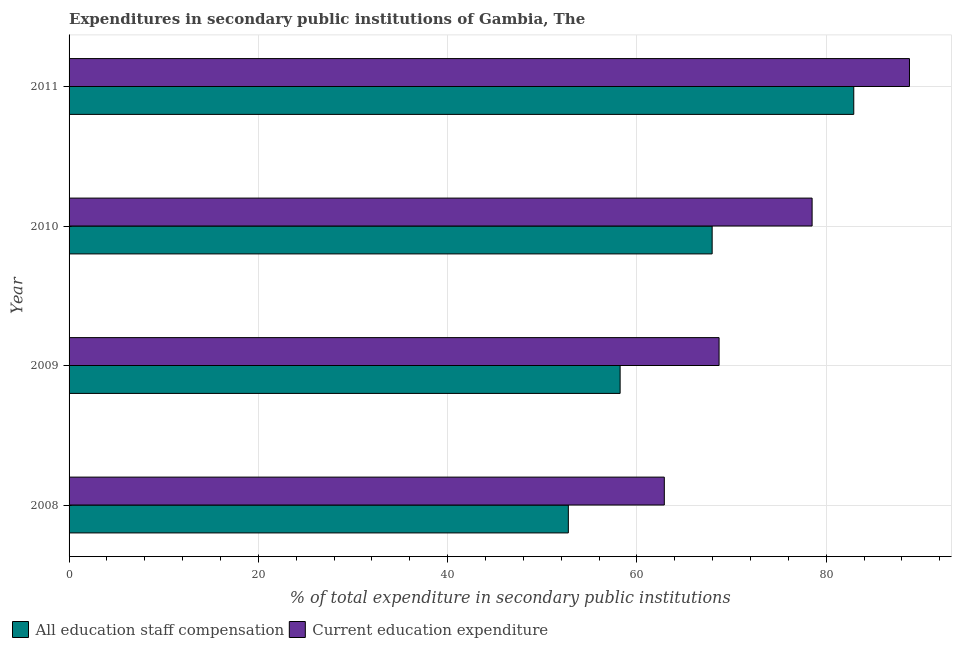Are the number of bars per tick equal to the number of legend labels?
Make the answer very short. Yes. How many bars are there on the 4th tick from the top?
Give a very brief answer. 2. How many bars are there on the 4th tick from the bottom?
Give a very brief answer. 2. What is the expenditure in education in 2009?
Your response must be concise. 68.69. Across all years, what is the maximum expenditure in staff compensation?
Your response must be concise. 82.92. Across all years, what is the minimum expenditure in education?
Provide a short and direct response. 62.9. In which year was the expenditure in education maximum?
Offer a terse response. 2011. What is the total expenditure in staff compensation in the graph?
Your answer should be very brief. 261.86. What is the difference between the expenditure in education in 2009 and that in 2010?
Offer a terse response. -9.83. What is the difference between the expenditure in education in 2011 and the expenditure in staff compensation in 2008?
Make the answer very short. 36.05. What is the average expenditure in staff compensation per year?
Keep it short and to the point. 65.47. In the year 2008, what is the difference between the expenditure in staff compensation and expenditure in education?
Your response must be concise. -10.14. What is the ratio of the expenditure in education in 2009 to that in 2011?
Provide a succinct answer. 0.77. Is the expenditure in education in 2008 less than that in 2009?
Your answer should be very brief. Yes. What is the difference between the highest and the second highest expenditure in education?
Provide a short and direct response. 10.29. What is the difference between the highest and the lowest expenditure in staff compensation?
Give a very brief answer. 30.16. In how many years, is the expenditure in education greater than the average expenditure in education taken over all years?
Make the answer very short. 2. What does the 1st bar from the top in 2009 represents?
Your answer should be very brief. Current education expenditure. What does the 1st bar from the bottom in 2008 represents?
Your answer should be compact. All education staff compensation. How many bars are there?
Offer a terse response. 8. How many years are there in the graph?
Your answer should be very brief. 4. What is the difference between two consecutive major ticks on the X-axis?
Your answer should be compact. 20. Where does the legend appear in the graph?
Your response must be concise. Bottom left. How many legend labels are there?
Offer a terse response. 2. What is the title of the graph?
Give a very brief answer. Expenditures in secondary public institutions of Gambia, The. What is the label or title of the X-axis?
Your answer should be very brief. % of total expenditure in secondary public institutions. What is the label or title of the Y-axis?
Keep it short and to the point. Year. What is the % of total expenditure in secondary public institutions of All education staff compensation in 2008?
Provide a short and direct response. 52.76. What is the % of total expenditure in secondary public institutions of Current education expenditure in 2008?
Your answer should be compact. 62.9. What is the % of total expenditure in secondary public institutions in All education staff compensation in 2009?
Give a very brief answer. 58.23. What is the % of total expenditure in secondary public institutions of Current education expenditure in 2009?
Keep it short and to the point. 68.69. What is the % of total expenditure in secondary public institutions in All education staff compensation in 2010?
Your response must be concise. 67.96. What is the % of total expenditure in secondary public institutions in Current education expenditure in 2010?
Offer a very short reply. 78.52. What is the % of total expenditure in secondary public institutions in All education staff compensation in 2011?
Offer a terse response. 82.92. What is the % of total expenditure in secondary public institutions of Current education expenditure in 2011?
Offer a terse response. 88.81. Across all years, what is the maximum % of total expenditure in secondary public institutions of All education staff compensation?
Give a very brief answer. 82.92. Across all years, what is the maximum % of total expenditure in secondary public institutions of Current education expenditure?
Give a very brief answer. 88.81. Across all years, what is the minimum % of total expenditure in secondary public institutions of All education staff compensation?
Give a very brief answer. 52.76. Across all years, what is the minimum % of total expenditure in secondary public institutions in Current education expenditure?
Keep it short and to the point. 62.9. What is the total % of total expenditure in secondary public institutions of All education staff compensation in the graph?
Your answer should be compact. 261.86. What is the total % of total expenditure in secondary public institutions in Current education expenditure in the graph?
Your answer should be very brief. 298.91. What is the difference between the % of total expenditure in secondary public institutions in All education staff compensation in 2008 and that in 2009?
Make the answer very short. -5.47. What is the difference between the % of total expenditure in secondary public institutions in Current education expenditure in 2008 and that in 2009?
Give a very brief answer. -5.79. What is the difference between the % of total expenditure in secondary public institutions in All education staff compensation in 2008 and that in 2010?
Provide a succinct answer. -15.2. What is the difference between the % of total expenditure in secondary public institutions of Current education expenditure in 2008 and that in 2010?
Offer a terse response. -15.62. What is the difference between the % of total expenditure in secondary public institutions in All education staff compensation in 2008 and that in 2011?
Make the answer very short. -30.16. What is the difference between the % of total expenditure in secondary public institutions of Current education expenditure in 2008 and that in 2011?
Keep it short and to the point. -25.91. What is the difference between the % of total expenditure in secondary public institutions of All education staff compensation in 2009 and that in 2010?
Your response must be concise. -9.73. What is the difference between the % of total expenditure in secondary public institutions of Current education expenditure in 2009 and that in 2010?
Ensure brevity in your answer.  -9.83. What is the difference between the % of total expenditure in secondary public institutions in All education staff compensation in 2009 and that in 2011?
Your answer should be very brief. -24.69. What is the difference between the % of total expenditure in secondary public institutions in Current education expenditure in 2009 and that in 2011?
Make the answer very short. -20.12. What is the difference between the % of total expenditure in secondary public institutions of All education staff compensation in 2010 and that in 2011?
Give a very brief answer. -14.96. What is the difference between the % of total expenditure in secondary public institutions in Current education expenditure in 2010 and that in 2011?
Offer a terse response. -10.29. What is the difference between the % of total expenditure in secondary public institutions in All education staff compensation in 2008 and the % of total expenditure in secondary public institutions in Current education expenditure in 2009?
Offer a very short reply. -15.93. What is the difference between the % of total expenditure in secondary public institutions of All education staff compensation in 2008 and the % of total expenditure in secondary public institutions of Current education expenditure in 2010?
Offer a terse response. -25.76. What is the difference between the % of total expenditure in secondary public institutions of All education staff compensation in 2008 and the % of total expenditure in secondary public institutions of Current education expenditure in 2011?
Give a very brief answer. -36.05. What is the difference between the % of total expenditure in secondary public institutions of All education staff compensation in 2009 and the % of total expenditure in secondary public institutions of Current education expenditure in 2010?
Make the answer very short. -20.29. What is the difference between the % of total expenditure in secondary public institutions in All education staff compensation in 2009 and the % of total expenditure in secondary public institutions in Current education expenditure in 2011?
Give a very brief answer. -30.57. What is the difference between the % of total expenditure in secondary public institutions in All education staff compensation in 2010 and the % of total expenditure in secondary public institutions in Current education expenditure in 2011?
Keep it short and to the point. -20.85. What is the average % of total expenditure in secondary public institutions in All education staff compensation per year?
Give a very brief answer. 65.47. What is the average % of total expenditure in secondary public institutions in Current education expenditure per year?
Offer a very short reply. 74.73. In the year 2008, what is the difference between the % of total expenditure in secondary public institutions of All education staff compensation and % of total expenditure in secondary public institutions of Current education expenditure?
Provide a short and direct response. -10.14. In the year 2009, what is the difference between the % of total expenditure in secondary public institutions in All education staff compensation and % of total expenditure in secondary public institutions in Current education expenditure?
Ensure brevity in your answer.  -10.46. In the year 2010, what is the difference between the % of total expenditure in secondary public institutions of All education staff compensation and % of total expenditure in secondary public institutions of Current education expenditure?
Offer a terse response. -10.56. In the year 2011, what is the difference between the % of total expenditure in secondary public institutions in All education staff compensation and % of total expenditure in secondary public institutions in Current education expenditure?
Ensure brevity in your answer.  -5.89. What is the ratio of the % of total expenditure in secondary public institutions of All education staff compensation in 2008 to that in 2009?
Provide a short and direct response. 0.91. What is the ratio of the % of total expenditure in secondary public institutions of Current education expenditure in 2008 to that in 2009?
Your answer should be very brief. 0.92. What is the ratio of the % of total expenditure in secondary public institutions of All education staff compensation in 2008 to that in 2010?
Your answer should be very brief. 0.78. What is the ratio of the % of total expenditure in secondary public institutions in Current education expenditure in 2008 to that in 2010?
Keep it short and to the point. 0.8. What is the ratio of the % of total expenditure in secondary public institutions in All education staff compensation in 2008 to that in 2011?
Provide a short and direct response. 0.64. What is the ratio of the % of total expenditure in secondary public institutions of Current education expenditure in 2008 to that in 2011?
Your answer should be compact. 0.71. What is the ratio of the % of total expenditure in secondary public institutions in All education staff compensation in 2009 to that in 2010?
Your answer should be very brief. 0.86. What is the ratio of the % of total expenditure in secondary public institutions of Current education expenditure in 2009 to that in 2010?
Ensure brevity in your answer.  0.87. What is the ratio of the % of total expenditure in secondary public institutions in All education staff compensation in 2009 to that in 2011?
Provide a short and direct response. 0.7. What is the ratio of the % of total expenditure in secondary public institutions in Current education expenditure in 2009 to that in 2011?
Provide a succinct answer. 0.77. What is the ratio of the % of total expenditure in secondary public institutions in All education staff compensation in 2010 to that in 2011?
Your answer should be very brief. 0.82. What is the ratio of the % of total expenditure in secondary public institutions of Current education expenditure in 2010 to that in 2011?
Offer a very short reply. 0.88. What is the difference between the highest and the second highest % of total expenditure in secondary public institutions of All education staff compensation?
Your response must be concise. 14.96. What is the difference between the highest and the second highest % of total expenditure in secondary public institutions of Current education expenditure?
Your response must be concise. 10.29. What is the difference between the highest and the lowest % of total expenditure in secondary public institutions of All education staff compensation?
Your answer should be compact. 30.16. What is the difference between the highest and the lowest % of total expenditure in secondary public institutions of Current education expenditure?
Provide a succinct answer. 25.91. 